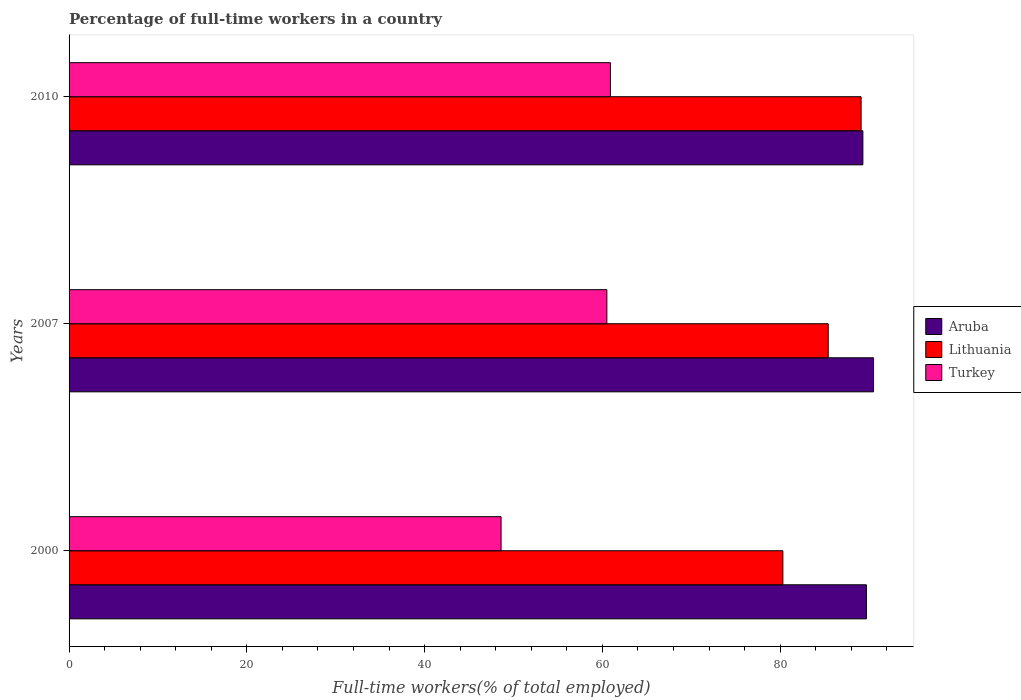How many different coloured bars are there?
Offer a terse response. 3. How many groups of bars are there?
Provide a short and direct response. 3. Are the number of bars per tick equal to the number of legend labels?
Offer a terse response. Yes. How many bars are there on the 1st tick from the bottom?
Keep it short and to the point. 3. What is the label of the 3rd group of bars from the top?
Offer a terse response. 2000. In how many cases, is the number of bars for a given year not equal to the number of legend labels?
Keep it short and to the point. 0. What is the percentage of full-time workers in Turkey in 2000?
Your answer should be compact. 48.6. Across all years, what is the maximum percentage of full-time workers in Aruba?
Give a very brief answer. 90.5. Across all years, what is the minimum percentage of full-time workers in Aruba?
Offer a very short reply. 89.3. What is the total percentage of full-time workers in Lithuania in the graph?
Your answer should be very brief. 254.8. What is the difference between the percentage of full-time workers in Aruba in 2007 and that in 2010?
Your response must be concise. 1.2. What is the difference between the percentage of full-time workers in Lithuania in 2000 and the percentage of full-time workers in Aruba in 2007?
Ensure brevity in your answer.  -10.2. What is the average percentage of full-time workers in Lithuania per year?
Your answer should be very brief. 84.93. What is the ratio of the percentage of full-time workers in Turkey in 2007 to that in 2010?
Make the answer very short. 0.99. Is the difference between the percentage of full-time workers in Aruba in 2000 and 2010 greater than the difference between the percentage of full-time workers in Turkey in 2000 and 2010?
Make the answer very short. Yes. What is the difference between the highest and the second highest percentage of full-time workers in Aruba?
Give a very brief answer. 0.8. What is the difference between the highest and the lowest percentage of full-time workers in Turkey?
Offer a terse response. 12.3. What does the 3rd bar from the top in 2010 represents?
Ensure brevity in your answer.  Aruba. What does the 1st bar from the bottom in 2010 represents?
Ensure brevity in your answer.  Aruba. Is it the case that in every year, the sum of the percentage of full-time workers in Lithuania and percentage of full-time workers in Turkey is greater than the percentage of full-time workers in Aruba?
Make the answer very short. Yes. Are all the bars in the graph horizontal?
Offer a very short reply. Yes. Does the graph contain any zero values?
Offer a very short reply. No. Does the graph contain grids?
Keep it short and to the point. No. How are the legend labels stacked?
Your answer should be very brief. Vertical. What is the title of the graph?
Ensure brevity in your answer.  Percentage of full-time workers in a country. What is the label or title of the X-axis?
Offer a terse response. Full-time workers(% of total employed). What is the label or title of the Y-axis?
Offer a very short reply. Years. What is the Full-time workers(% of total employed) in Aruba in 2000?
Keep it short and to the point. 89.7. What is the Full-time workers(% of total employed) in Lithuania in 2000?
Keep it short and to the point. 80.3. What is the Full-time workers(% of total employed) of Turkey in 2000?
Ensure brevity in your answer.  48.6. What is the Full-time workers(% of total employed) of Aruba in 2007?
Ensure brevity in your answer.  90.5. What is the Full-time workers(% of total employed) in Lithuania in 2007?
Your response must be concise. 85.4. What is the Full-time workers(% of total employed) in Turkey in 2007?
Provide a short and direct response. 60.5. What is the Full-time workers(% of total employed) of Aruba in 2010?
Offer a very short reply. 89.3. What is the Full-time workers(% of total employed) in Lithuania in 2010?
Provide a short and direct response. 89.1. What is the Full-time workers(% of total employed) in Turkey in 2010?
Make the answer very short. 60.9. Across all years, what is the maximum Full-time workers(% of total employed) of Aruba?
Make the answer very short. 90.5. Across all years, what is the maximum Full-time workers(% of total employed) of Lithuania?
Keep it short and to the point. 89.1. Across all years, what is the maximum Full-time workers(% of total employed) in Turkey?
Your answer should be very brief. 60.9. Across all years, what is the minimum Full-time workers(% of total employed) in Aruba?
Provide a succinct answer. 89.3. Across all years, what is the minimum Full-time workers(% of total employed) of Lithuania?
Give a very brief answer. 80.3. Across all years, what is the minimum Full-time workers(% of total employed) of Turkey?
Your answer should be very brief. 48.6. What is the total Full-time workers(% of total employed) of Aruba in the graph?
Your answer should be compact. 269.5. What is the total Full-time workers(% of total employed) in Lithuania in the graph?
Your answer should be compact. 254.8. What is the total Full-time workers(% of total employed) in Turkey in the graph?
Keep it short and to the point. 170. What is the difference between the Full-time workers(% of total employed) of Aruba in 2000 and that in 2007?
Give a very brief answer. -0.8. What is the difference between the Full-time workers(% of total employed) of Turkey in 2000 and that in 2007?
Your answer should be compact. -11.9. What is the difference between the Full-time workers(% of total employed) in Lithuania in 2007 and that in 2010?
Your answer should be very brief. -3.7. What is the difference between the Full-time workers(% of total employed) of Aruba in 2000 and the Full-time workers(% of total employed) of Turkey in 2007?
Provide a short and direct response. 29.2. What is the difference between the Full-time workers(% of total employed) of Lithuania in 2000 and the Full-time workers(% of total employed) of Turkey in 2007?
Offer a terse response. 19.8. What is the difference between the Full-time workers(% of total employed) in Aruba in 2000 and the Full-time workers(% of total employed) in Turkey in 2010?
Provide a short and direct response. 28.8. What is the difference between the Full-time workers(% of total employed) of Aruba in 2007 and the Full-time workers(% of total employed) of Lithuania in 2010?
Give a very brief answer. 1.4. What is the difference between the Full-time workers(% of total employed) in Aruba in 2007 and the Full-time workers(% of total employed) in Turkey in 2010?
Your response must be concise. 29.6. What is the difference between the Full-time workers(% of total employed) in Lithuania in 2007 and the Full-time workers(% of total employed) in Turkey in 2010?
Make the answer very short. 24.5. What is the average Full-time workers(% of total employed) of Aruba per year?
Keep it short and to the point. 89.83. What is the average Full-time workers(% of total employed) of Lithuania per year?
Your response must be concise. 84.93. What is the average Full-time workers(% of total employed) in Turkey per year?
Offer a very short reply. 56.67. In the year 2000, what is the difference between the Full-time workers(% of total employed) in Aruba and Full-time workers(% of total employed) in Turkey?
Give a very brief answer. 41.1. In the year 2000, what is the difference between the Full-time workers(% of total employed) of Lithuania and Full-time workers(% of total employed) of Turkey?
Give a very brief answer. 31.7. In the year 2007, what is the difference between the Full-time workers(% of total employed) of Lithuania and Full-time workers(% of total employed) of Turkey?
Provide a short and direct response. 24.9. In the year 2010, what is the difference between the Full-time workers(% of total employed) of Aruba and Full-time workers(% of total employed) of Lithuania?
Keep it short and to the point. 0.2. In the year 2010, what is the difference between the Full-time workers(% of total employed) of Aruba and Full-time workers(% of total employed) of Turkey?
Your answer should be very brief. 28.4. In the year 2010, what is the difference between the Full-time workers(% of total employed) of Lithuania and Full-time workers(% of total employed) of Turkey?
Your answer should be very brief. 28.2. What is the ratio of the Full-time workers(% of total employed) in Lithuania in 2000 to that in 2007?
Provide a short and direct response. 0.94. What is the ratio of the Full-time workers(% of total employed) in Turkey in 2000 to that in 2007?
Provide a succinct answer. 0.8. What is the ratio of the Full-time workers(% of total employed) in Aruba in 2000 to that in 2010?
Keep it short and to the point. 1. What is the ratio of the Full-time workers(% of total employed) in Lithuania in 2000 to that in 2010?
Your answer should be very brief. 0.9. What is the ratio of the Full-time workers(% of total employed) of Turkey in 2000 to that in 2010?
Keep it short and to the point. 0.8. What is the ratio of the Full-time workers(% of total employed) of Aruba in 2007 to that in 2010?
Give a very brief answer. 1.01. What is the ratio of the Full-time workers(% of total employed) of Lithuania in 2007 to that in 2010?
Make the answer very short. 0.96. What is the difference between the highest and the second highest Full-time workers(% of total employed) of Aruba?
Ensure brevity in your answer.  0.8. What is the difference between the highest and the second highest Full-time workers(% of total employed) of Lithuania?
Provide a short and direct response. 3.7. What is the difference between the highest and the lowest Full-time workers(% of total employed) in Lithuania?
Make the answer very short. 8.8. What is the difference between the highest and the lowest Full-time workers(% of total employed) of Turkey?
Your answer should be very brief. 12.3. 